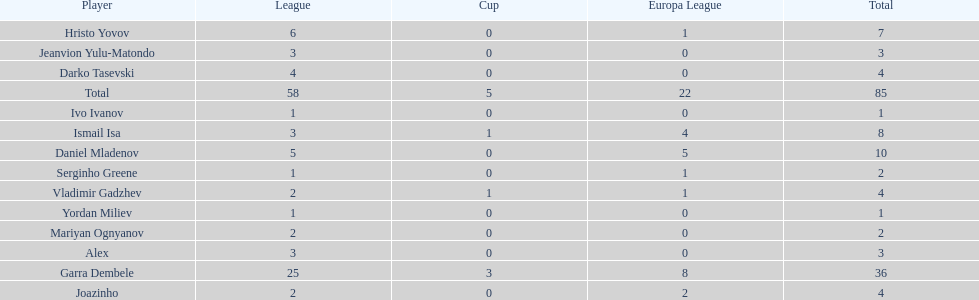Which athletes only scored a single goal? Serginho Greene, Yordan Miliev, Ivo Ivanov. 